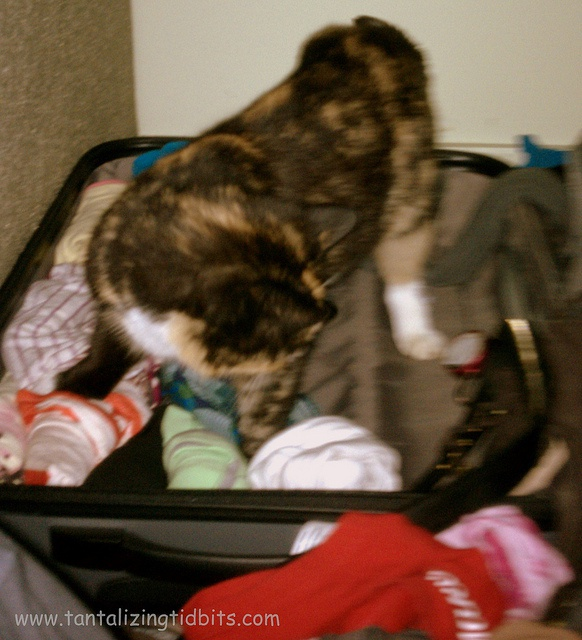Describe the objects in this image and their specific colors. I can see suitcase in gray, black, and darkgray tones and cat in gray, black, maroon, and olive tones in this image. 